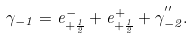Convert formula to latex. <formula><loc_0><loc_0><loc_500><loc_500>\gamma _ { - 1 } = e ^ { - } _ { + \frac { 1 } { 2 } } + e ^ { + } _ { + \frac { 1 } { 2 } } + \gamma ^ { ^ { \prime \prime } } _ { - 2 } .</formula> 